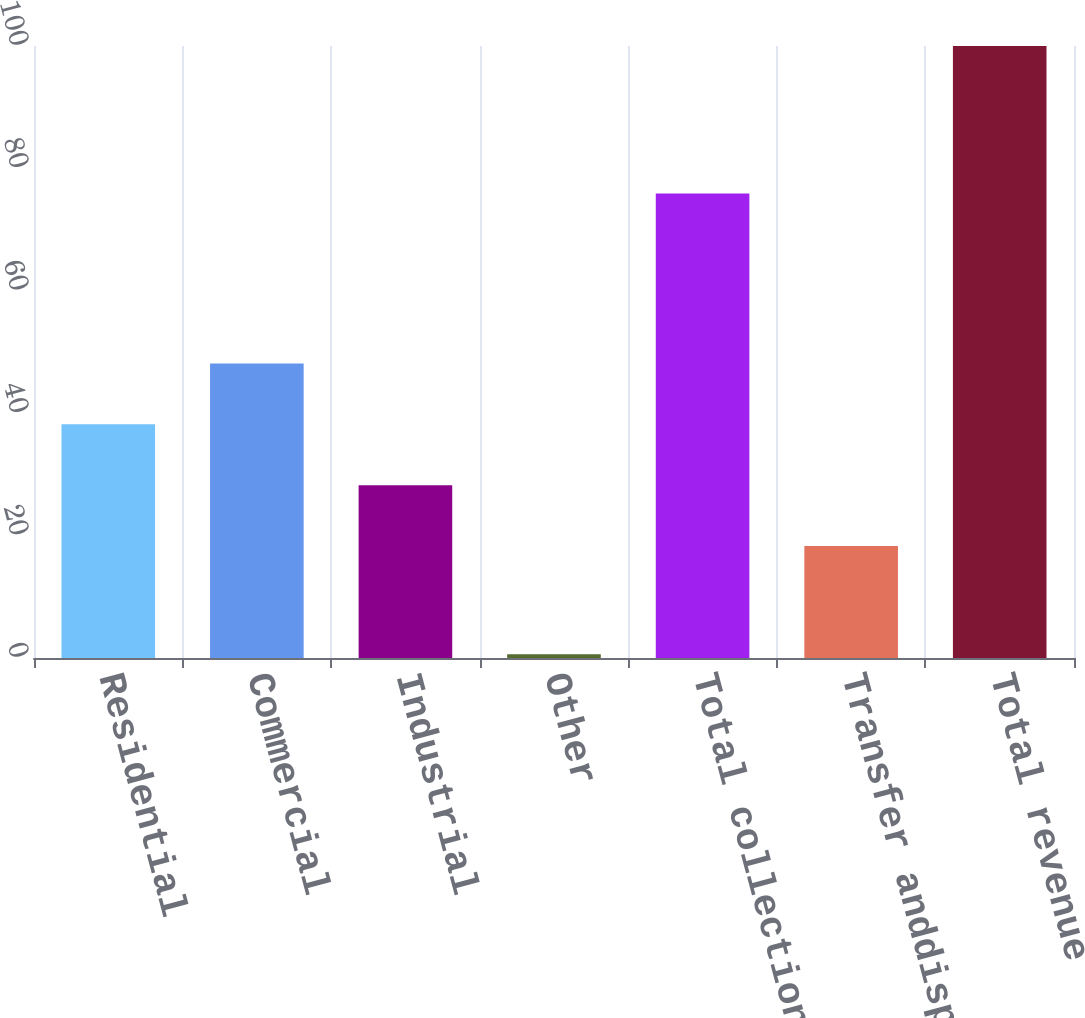Convert chart. <chart><loc_0><loc_0><loc_500><loc_500><bar_chart><fcel>Residential<fcel>Commercial<fcel>Industrial<fcel>Other<fcel>Total collection<fcel>Transfer anddisposal net<fcel>Total revenue<nl><fcel>38.18<fcel>48.12<fcel>28.24<fcel>0.6<fcel>75.9<fcel>18.3<fcel>100<nl></chart> 